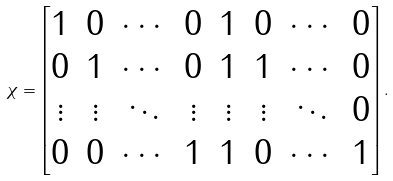<formula> <loc_0><loc_0><loc_500><loc_500>\chi = \begin{bmatrix} 1 & 0 & \cdots & 0 & 1 & 0 & \cdots & 0 \\ 0 & 1 & \cdots & 0 & 1 & 1 & \cdots & 0 \\ \vdots & \vdots & \ddots & \vdots & \vdots & \vdots & \ddots & 0 \\ 0 & 0 & \cdots & 1 & 1 & 0 & \cdots & 1 \end{bmatrix} .</formula> 